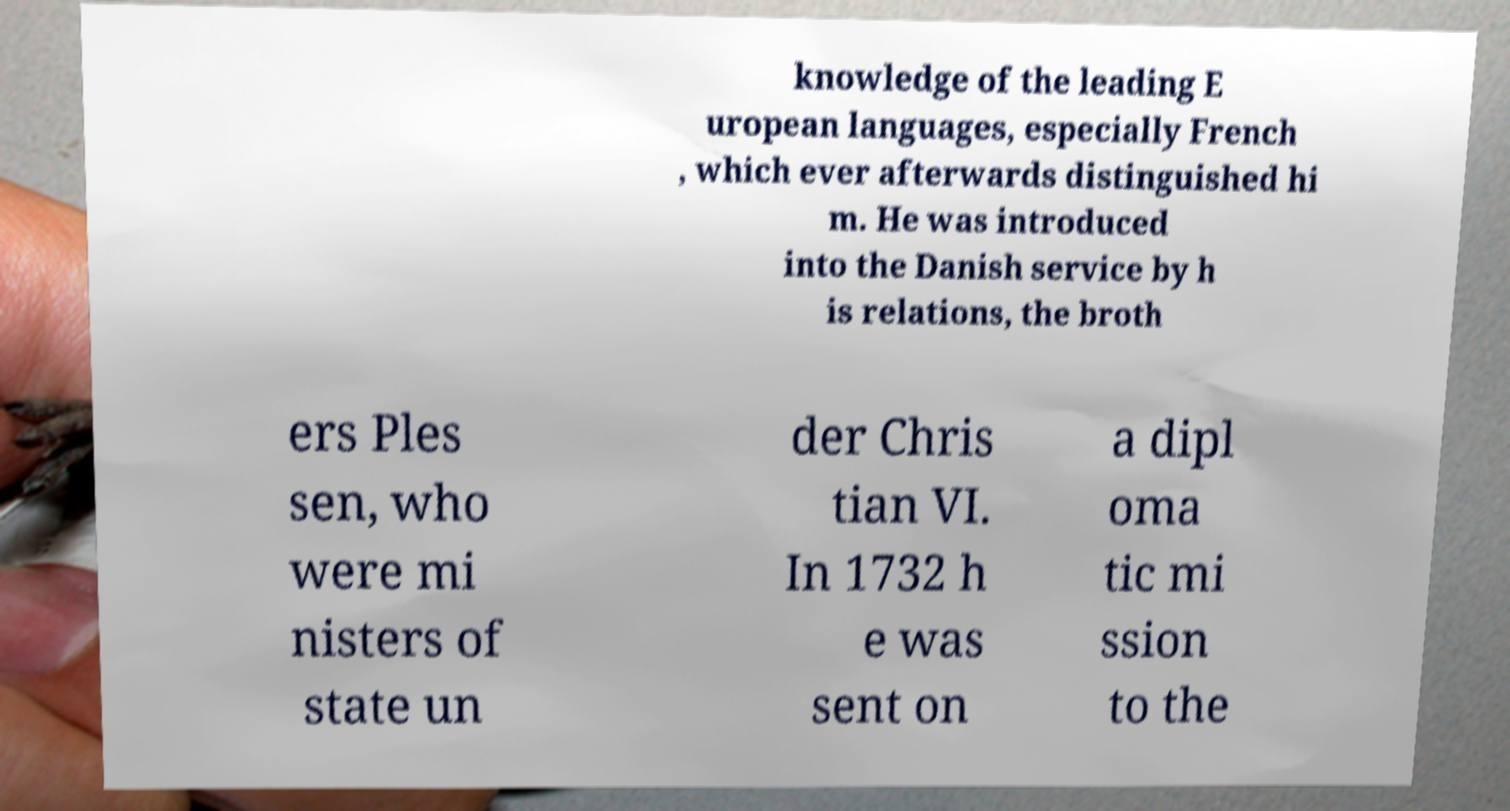For documentation purposes, I need the text within this image transcribed. Could you provide that? knowledge of the leading E uropean languages, especially French , which ever afterwards distinguished hi m. He was introduced into the Danish service by h is relations, the broth ers Ples sen, who were mi nisters of state un der Chris tian VI. In 1732 h e was sent on a dipl oma tic mi ssion to the 